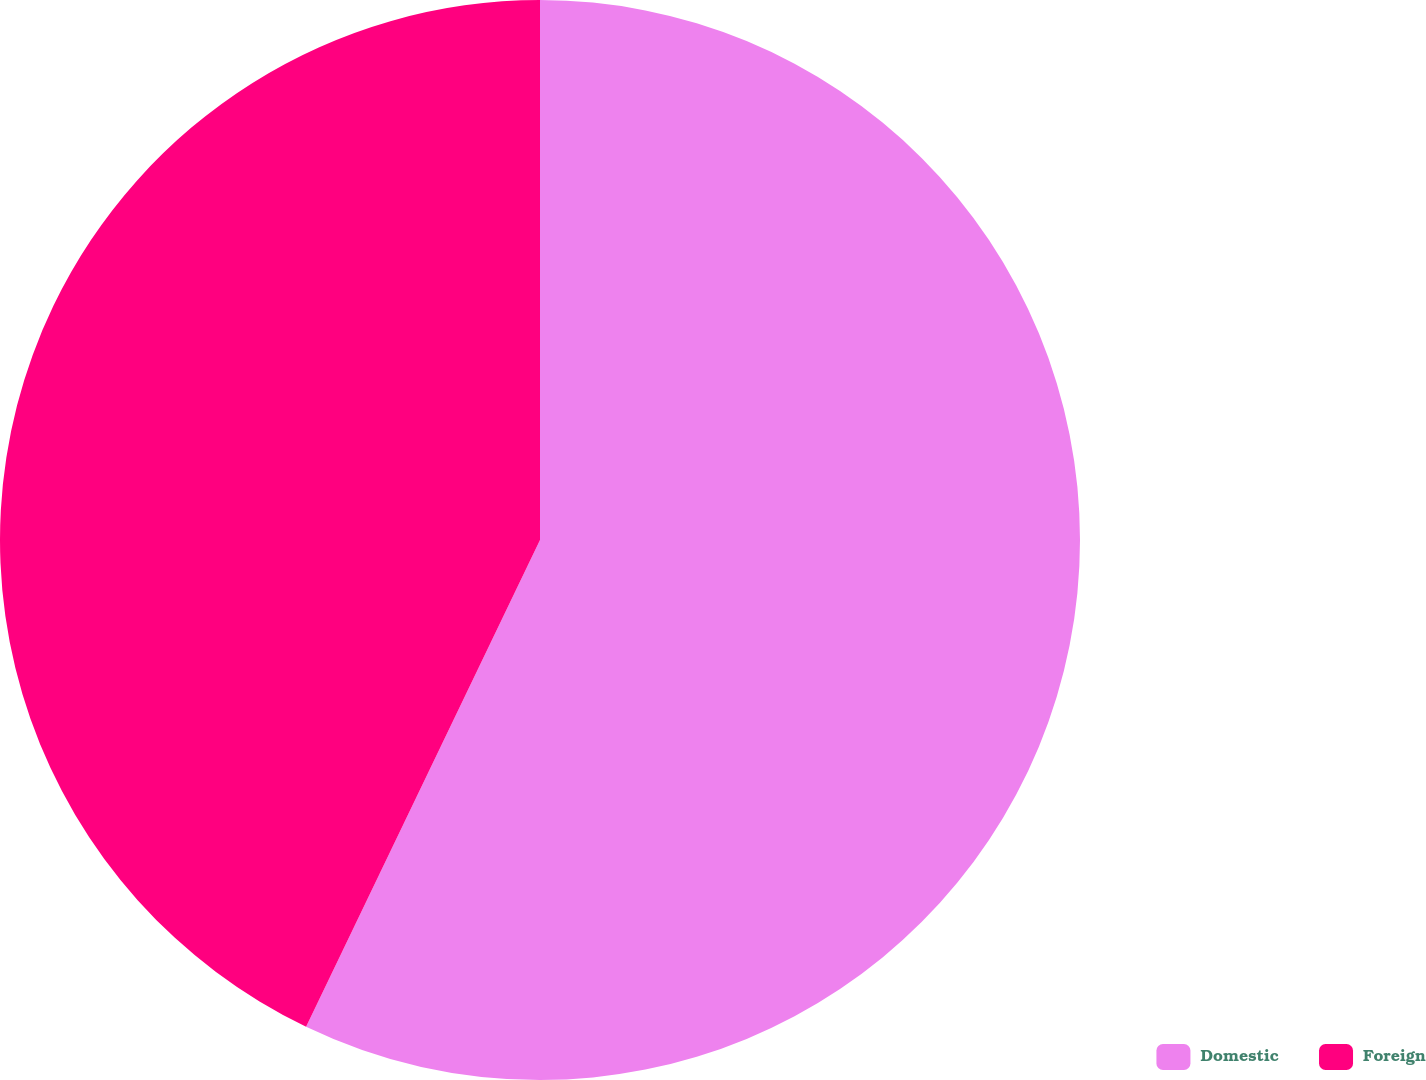<chart> <loc_0><loc_0><loc_500><loc_500><pie_chart><fcel>Domestic<fcel>Foreign<nl><fcel>57.13%<fcel>42.87%<nl></chart> 